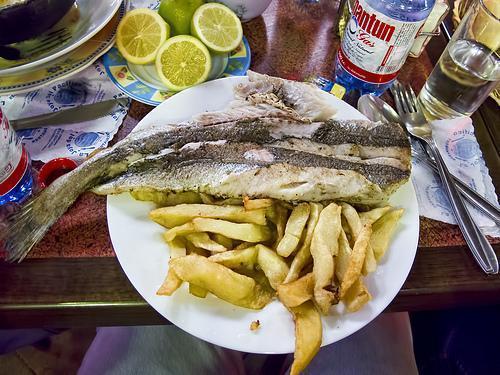How many bottle lids are on the table?
Give a very brief answer. 1. How many lime halves are shown?
Give a very brief answer. 3. 